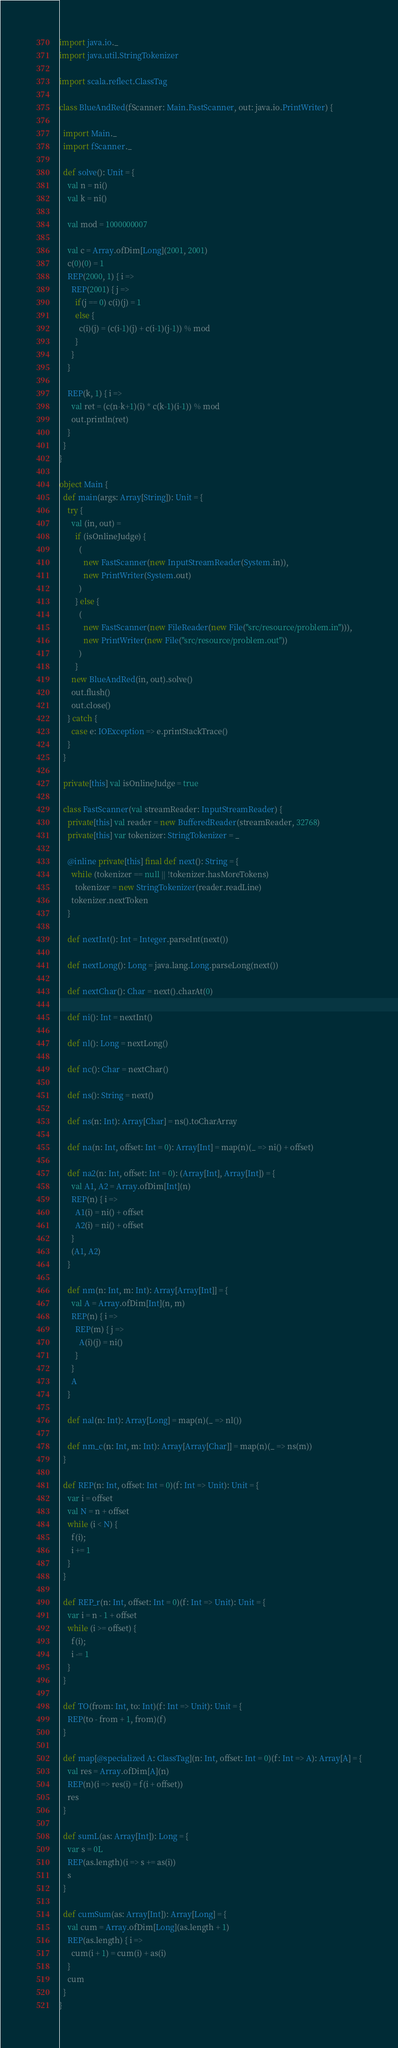Convert code to text. <code><loc_0><loc_0><loc_500><loc_500><_Scala_>import java.io._
import java.util.StringTokenizer

import scala.reflect.ClassTag

class BlueAndRed(fScanner: Main.FastScanner, out: java.io.PrintWriter) {

  import Main._
  import fScanner._

  def solve(): Unit = {
    val n = ni()
    val k = ni()

    val mod = 1000000007

    val c = Array.ofDim[Long](2001, 2001)
    c(0)(0) = 1
    REP(2000, 1) { i =>
      REP(2001) { j =>
        if(j == 0) c(i)(j) = 1
        else {
          c(i)(j) = (c(i-1)(j) + c(i-1)(j-1)) % mod
        }
      }
    }

    REP(k, 1) { i =>
      val ret = (c(n-k+1)(i) * c(k-1)(i-1)) % mod
      out.println(ret)
    }
  }
}

object Main {
  def main(args: Array[String]): Unit = {
    try {
      val (in, out) =
        if (isOnlineJudge) {
          (
            new FastScanner(new InputStreamReader(System.in)),
            new PrintWriter(System.out)
          )
        } else {
          (
            new FastScanner(new FileReader(new File("src/resource/problem.in"))),
            new PrintWriter(new File("src/resource/problem.out"))
          )
        }
      new BlueAndRed(in, out).solve()
      out.flush()
      out.close()
    } catch {
      case e: IOException => e.printStackTrace()
    }
  }

  private[this] val isOnlineJudge = true

  class FastScanner(val streamReader: InputStreamReader) {
    private[this] val reader = new BufferedReader(streamReader, 32768)
    private[this] var tokenizer: StringTokenizer = _

    @inline private[this] final def next(): String = {
      while (tokenizer == null || !tokenizer.hasMoreTokens)
        tokenizer = new StringTokenizer(reader.readLine)
      tokenizer.nextToken
    }

    def nextInt(): Int = Integer.parseInt(next())

    def nextLong(): Long = java.lang.Long.parseLong(next())

    def nextChar(): Char = next().charAt(0)

    def ni(): Int = nextInt()

    def nl(): Long = nextLong()

    def nc(): Char = nextChar()

    def ns(): String = next()

    def ns(n: Int): Array[Char] = ns().toCharArray

    def na(n: Int, offset: Int = 0): Array[Int] = map(n)(_ => ni() + offset)

    def na2(n: Int, offset: Int = 0): (Array[Int], Array[Int]) = {
      val A1, A2 = Array.ofDim[Int](n)
      REP(n) { i =>
        A1(i) = ni() + offset
        A2(i) = ni() + offset
      }
      (A1, A2)
    }

    def nm(n: Int, m: Int): Array[Array[Int]] = {
      val A = Array.ofDim[Int](n, m)
      REP(n) { i =>
        REP(m) { j =>
          A(i)(j) = ni()
        }
      }
      A
    }

    def nal(n: Int): Array[Long] = map(n)(_ => nl())

    def nm_c(n: Int, m: Int): Array[Array[Char]] = map(n)(_ => ns(m))
  }

  def REP(n: Int, offset: Int = 0)(f: Int => Unit): Unit = {
    var i = offset
    val N = n + offset
    while (i < N) {
      f(i);
      i += 1
    }
  }

  def REP_r(n: Int, offset: Int = 0)(f: Int => Unit): Unit = {
    var i = n - 1 + offset
    while (i >= offset) {
      f(i);
      i -= 1
    }
  }

  def TO(from: Int, to: Int)(f: Int => Unit): Unit = {
    REP(to - from + 1, from)(f)
  }

  def map[@specialized A: ClassTag](n: Int, offset: Int = 0)(f: Int => A): Array[A] = {
    val res = Array.ofDim[A](n)
    REP(n)(i => res(i) = f(i + offset))
    res
  }

  def sumL(as: Array[Int]): Long = {
    var s = 0L
    REP(as.length)(i => s += as(i))
    s
  }

  def cumSum(as: Array[Int]): Array[Long] = {
    val cum = Array.ofDim[Long](as.length + 1)
    REP(as.length) { i =>
      cum(i + 1) = cum(i) + as(i)
    }
    cum
  }
}
</code> 